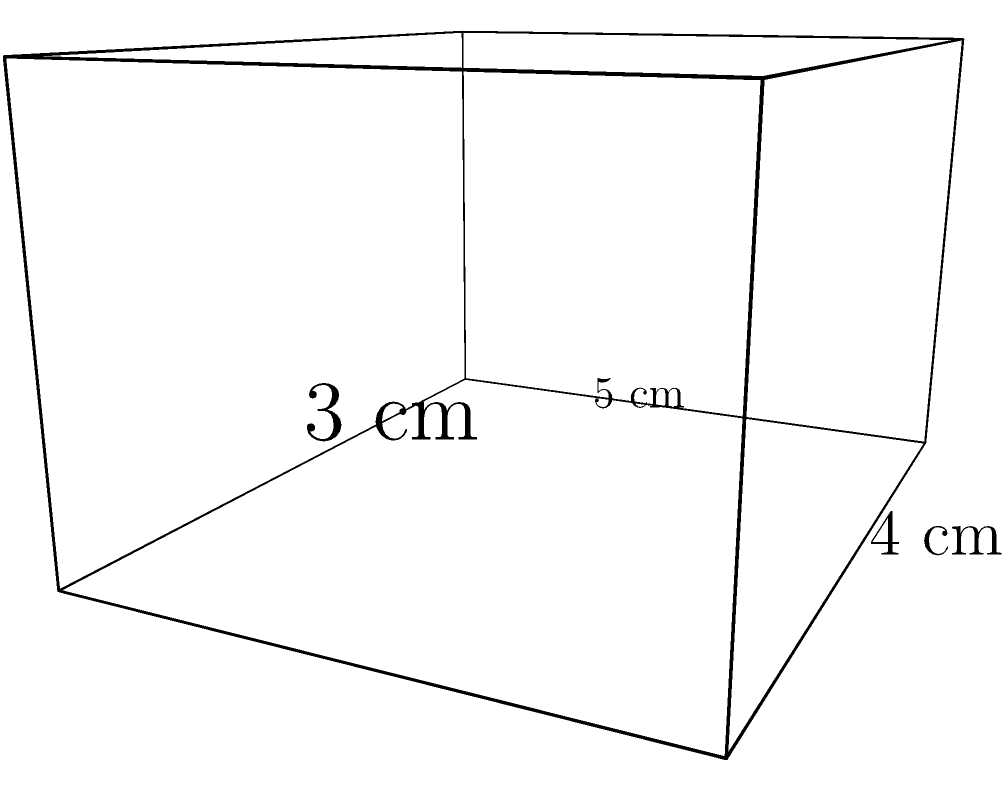A multilingual job-seeker is carrying a compact dictionary for their international interviews. The dictionary is shaped like a rectangular prism with dimensions 5 cm × 4 cm × 3 cm. What is the volume of this multilingual dictionary in cubic centimeters? To calculate the volume of a rectangular prism, we need to multiply its length, width, and height.

Given dimensions:
Length (l) = 5 cm
Width (w) = 4 cm
Height (h) = 3 cm

The formula for the volume of a rectangular prism is:
$$V = l \times w \times h$$

Substituting the values:
$$V = 5 \text{ cm} \times 4 \text{ cm} \times 3 \text{ cm}$$

Calculating:
$$V = 60 \text{ cm}^3$$

Therefore, the volume of the multilingual dictionary is 60 cubic centimeters.
Answer: 60 cm³ 